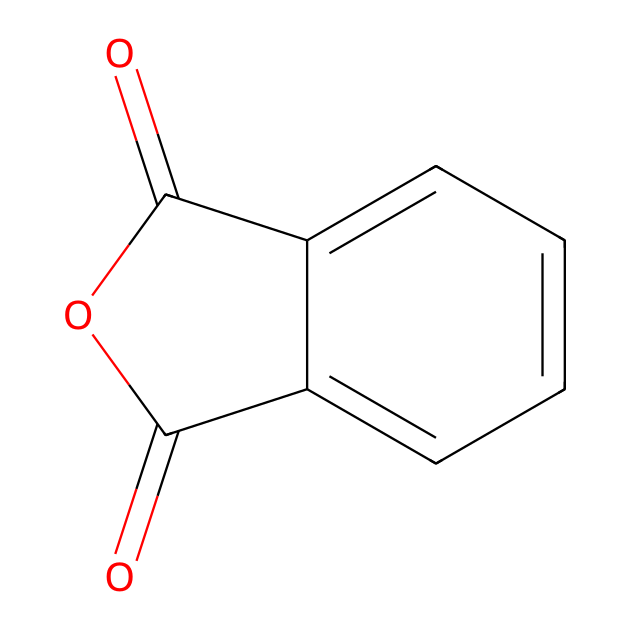What is the molecular formula of phthalic anhydride? To determine the molecular formula, count the atoms in the structure: there are 8 carbons (C), 4 oxygens (O), and 4 hydrogens (H). The molecular formula is derived from this count.
Answer: C8H4O3 How many carbon atoms are present in phthalic anhydride? By examining the chemical structure, count the distinct carbon atoms represented in the rings and chains. In this case, there are 8 carbon atoms.
Answer: 8 How many functional groups are present in phthalic anhydride? The chemical contains a cyclic anhydride structure, which is characterized by the presence of two anhydride functional groups. Thus, the total is two functional groups.
Answer: 2 What type of chemical structure is phthalic anhydride classified as? Analyzing the presence of an anhydride linkage and the arrangement of rings, phthalic anhydride is classified as a cyclic anhydride, which is a specific type of acid anhydride.
Answer: cyclic anhydride What type of bonds are present between the carbon and oxygen atoms in phthalic anhydride? By inspecting the structure, you can observe that the carbon atoms are connected to oxygen atoms via double bonds (C=O), characteristic of carbonyl groups. Therefore, the type of bonds present is double bonds.
Answer: double bonds What is the common industrial use of phthalic anhydride? Phthalic anhydride is primarily used to produce plasticizers, which are commonly added to plastics to improve flexibility and workability.
Answer: plasticizers 